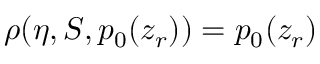<formula> <loc_0><loc_0><loc_500><loc_500>\rho ( \eta , S , p _ { 0 } ( z _ { r } ) ) = p _ { 0 } ( z _ { r } )</formula> 